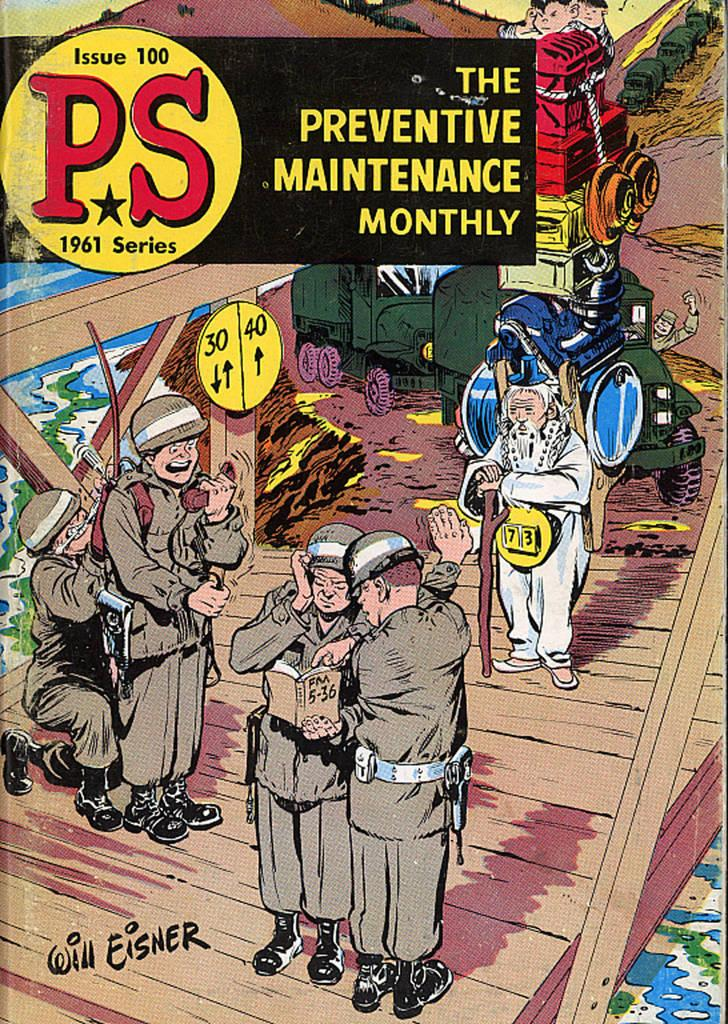<image>
Give a short and clear explanation of the subsequent image. Issue 100 of The Preventive Maintenance Monthly shows men in uniforms on the cover. 